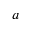<formula> <loc_0><loc_0><loc_500><loc_500>a</formula> 